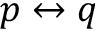<formula> <loc_0><loc_0><loc_500><loc_500>p \leftrightarrow q</formula> 